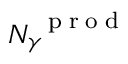<formula> <loc_0><loc_0><loc_500><loc_500>N _ { \gamma } ^ { p r o d }</formula> 